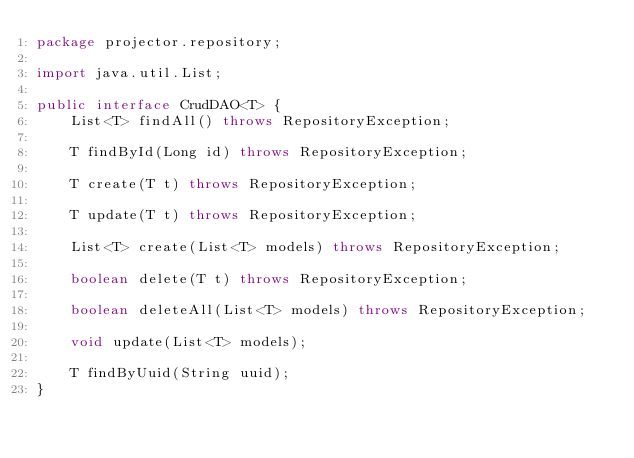Convert code to text. <code><loc_0><loc_0><loc_500><loc_500><_Java_>package projector.repository;

import java.util.List;

public interface CrudDAO<T> {
    List<T> findAll() throws RepositoryException;

    T findById(Long id) throws RepositoryException;

    T create(T t) throws RepositoryException;

    T update(T t) throws RepositoryException;

    List<T> create(List<T> models) throws RepositoryException;

    boolean delete(T t) throws RepositoryException;

    boolean deleteAll(List<T> models) throws RepositoryException;

    void update(List<T> models);

    T findByUuid(String uuid);
}
</code> 